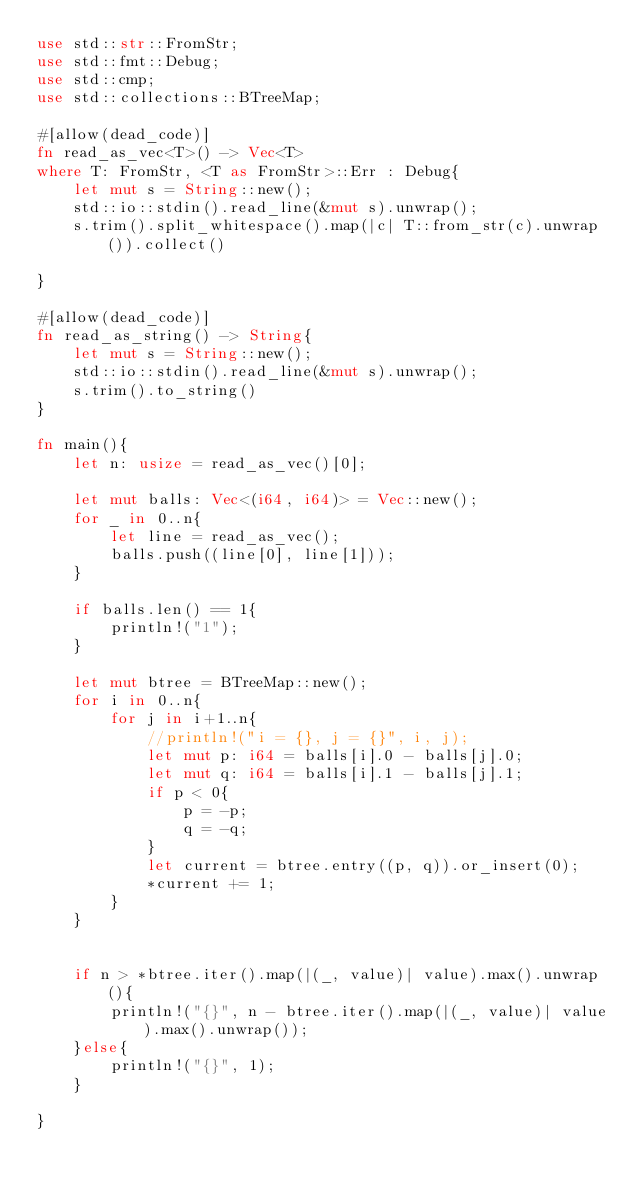Convert code to text. <code><loc_0><loc_0><loc_500><loc_500><_Rust_>use std::str::FromStr;
use std::fmt::Debug;
use std::cmp;
use std::collections::BTreeMap;

#[allow(dead_code)]
fn read_as_vec<T>() -> Vec<T>
where T: FromStr, <T as FromStr>::Err : Debug{
    let mut s = String::new();
    std::io::stdin().read_line(&mut s).unwrap();
    s.trim().split_whitespace().map(|c| T::from_str(c).unwrap()).collect()

}

#[allow(dead_code)]
fn read_as_string() -> String{
    let mut s = String::new();
    std::io::stdin().read_line(&mut s).unwrap();
    s.trim().to_string()
}

fn main(){
    let n: usize = read_as_vec()[0];

    let mut balls: Vec<(i64, i64)> = Vec::new();
    for _ in 0..n{
        let line = read_as_vec();
        balls.push((line[0], line[1]));
    }

    if balls.len() == 1{
        println!("1");
    }
    
    let mut btree = BTreeMap::new();
    for i in 0..n{
        for j in i+1..n{
            //println!("i = {}, j = {}", i, j);
            let mut p: i64 = balls[i].0 - balls[j].0;
            let mut q: i64 = balls[i].1 - balls[j].1;
            if p < 0{
                p = -p;
                q = -q;
            }
            let current = btree.entry((p, q)).or_insert(0);
            *current += 1;
        }
    }

    
    if n > *btree.iter().map(|(_, value)| value).max().unwrap(){
        println!("{}", n - btree.iter().map(|(_, value)| value).max().unwrap());
    }else{
        println!("{}", 1);
    }
 
}
</code> 